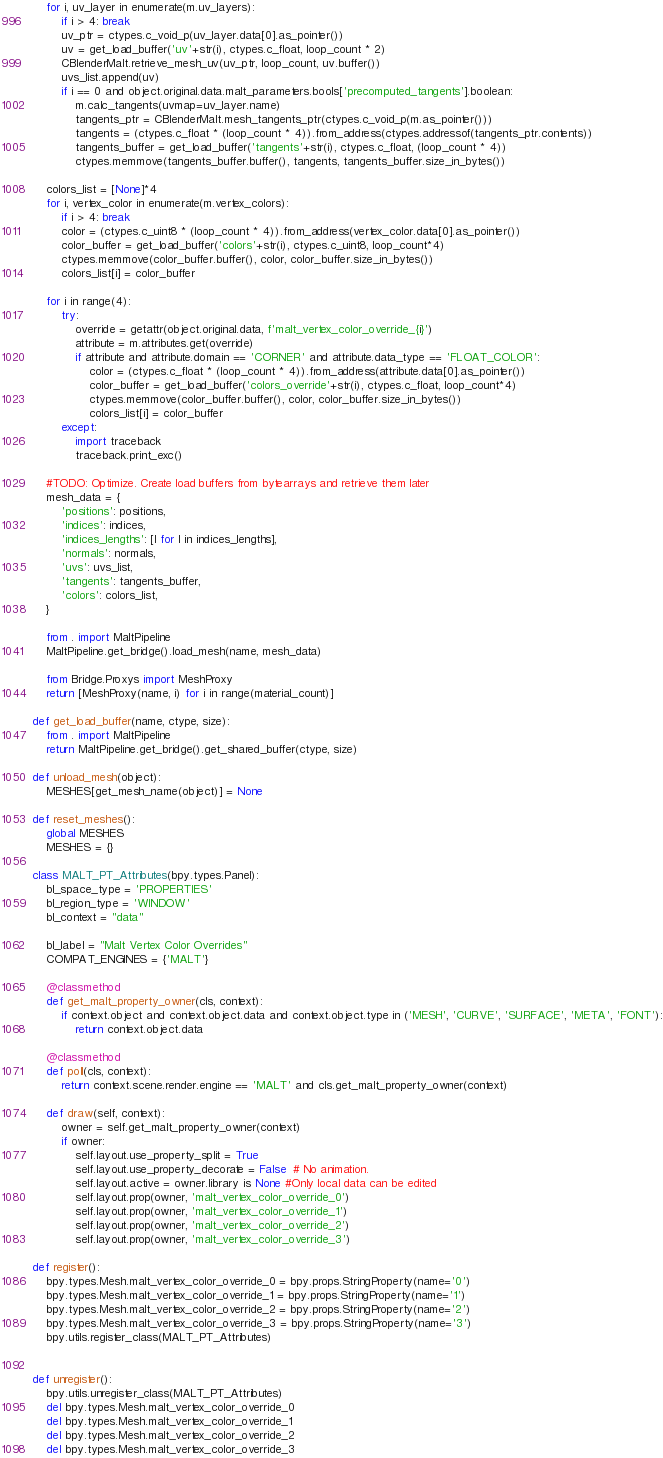<code> <loc_0><loc_0><loc_500><loc_500><_Python_>    for i, uv_layer in enumerate(m.uv_layers):
        if i > 4: break
        uv_ptr = ctypes.c_void_p(uv_layer.data[0].as_pointer())
        uv = get_load_buffer('uv'+str(i), ctypes.c_float, loop_count * 2)
        CBlenderMalt.retrieve_mesh_uv(uv_ptr, loop_count, uv.buffer())
        uvs_list.append(uv)
        if i == 0 and object.original.data.malt_parameters.bools['precomputed_tangents'].boolean:
            m.calc_tangents(uvmap=uv_layer.name)
            tangents_ptr = CBlenderMalt.mesh_tangents_ptr(ctypes.c_void_p(m.as_pointer()))
            tangents = (ctypes.c_float * (loop_count * 4)).from_address(ctypes.addressof(tangents_ptr.contents))
            tangents_buffer = get_load_buffer('tangents'+str(i), ctypes.c_float, (loop_count * 4))
            ctypes.memmove(tangents_buffer.buffer(), tangents, tangents_buffer.size_in_bytes())
    
    colors_list = [None]*4
    for i, vertex_color in enumerate(m.vertex_colors):
        if i > 4: break
        color = (ctypes.c_uint8 * (loop_count * 4)).from_address(vertex_color.data[0].as_pointer())
        color_buffer = get_load_buffer('colors'+str(i), ctypes.c_uint8, loop_count*4)
        ctypes.memmove(color_buffer.buffer(), color, color_buffer.size_in_bytes())
        colors_list[i] = color_buffer
    
    for i in range(4):
        try:
            override = getattr(object.original.data, f'malt_vertex_color_override_{i}')
            attribute = m.attributes.get(override)
            if attribute and attribute.domain == 'CORNER' and attribute.data_type == 'FLOAT_COLOR':
                color = (ctypes.c_float * (loop_count * 4)).from_address(attribute.data[0].as_pointer())
                color_buffer = get_load_buffer('colors_override'+str(i), ctypes.c_float, loop_count*4)
                ctypes.memmove(color_buffer.buffer(), color, color_buffer.size_in_bytes())
                colors_list[i] = color_buffer
        except:
            import traceback
            traceback.print_exc()

    #TODO: Optimize. Create load buffers from bytearrays and retrieve them later
    mesh_data = {
        'positions': positions,
        'indices': indices,
        'indices_lengths': [l for l in indices_lengths],
        'normals': normals,
        'uvs': uvs_list,
        'tangents': tangents_buffer,
        'colors': colors_list,
    }

    from . import MaltPipeline
    MaltPipeline.get_bridge().load_mesh(name, mesh_data)

    from Bridge.Proxys import MeshProxy
    return [MeshProxy(name, i) for i in range(material_count)]

def get_load_buffer(name, ctype, size):
    from . import MaltPipeline
    return MaltPipeline.get_bridge().get_shared_buffer(ctype, size)

def unload_mesh(object):
    MESHES[get_mesh_name(object)] = None

def reset_meshes():
    global MESHES
    MESHES = {}

class MALT_PT_Attributes(bpy.types.Panel):
    bl_space_type = 'PROPERTIES'
    bl_region_type = 'WINDOW'
    bl_context = "data"

    bl_label = "Malt Vertex Color Overrides"
    COMPAT_ENGINES = {'MALT'}

    @classmethod
    def get_malt_property_owner(cls, context):
        if context.object and context.object.data and context.object.type in ('MESH', 'CURVE', 'SURFACE', 'META', 'FONT'):
            return context.object.data
    
    @classmethod
    def poll(cls, context):
        return context.scene.render.engine == 'MALT' and cls.get_malt_property_owner(context)
    
    def draw(self, context):
        owner = self.get_malt_property_owner(context)
        if owner:
            self.layout.use_property_split = True
            self.layout.use_property_decorate = False  # No animation.
            self.layout.active = owner.library is None #Only local data can be edited
            self.layout.prop(owner, 'malt_vertex_color_override_0')    
            self.layout.prop(owner, 'malt_vertex_color_override_1')    
            self.layout.prop(owner, 'malt_vertex_color_override_2')    
            self.layout.prop(owner, 'malt_vertex_color_override_3')    

def register():
    bpy.types.Mesh.malt_vertex_color_override_0 = bpy.props.StringProperty(name='0')
    bpy.types.Mesh.malt_vertex_color_override_1 = bpy.props.StringProperty(name='1')
    bpy.types.Mesh.malt_vertex_color_override_2 = bpy.props.StringProperty(name='2')
    bpy.types.Mesh.malt_vertex_color_override_3 = bpy.props.StringProperty(name='3')
    bpy.utils.register_class(MALT_PT_Attributes)


def unregister():
    bpy.utils.unregister_class(MALT_PT_Attributes)
    del bpy.types.Mesh.malt_vertex_color_override_0
    del bpy.types.Mesh.malt_vertex_color_override_1
    del bpy.types.Mesh.malt_vertex_color_override_2
    del bpy.types.Mesh.malt_vertex_color_override_3

</code> 